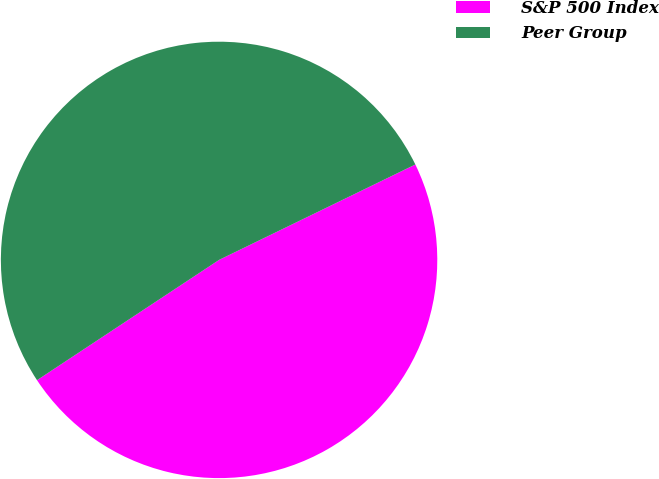Convert chart to OTSL. <chart><loc_0><loc_0><loc_500><loc_500><pie_chart><fcel>S&P 500 Index<fcel>Peer Group<nl><fcel>47.91%<fcel>52.09%<nl></chart> 